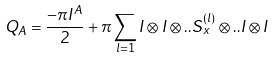Convert formula to latex. <formula><loc_0><loc_0><loc_500><loc_500>Q _ { A } = \frac { - \pi I ^ { A } } { 2 } + \pi \sum _ { l = 1 } I \otimes I \otimes . . S _ { x } ^ { ( l ) } \otimes . . I \otimes I</formula> 